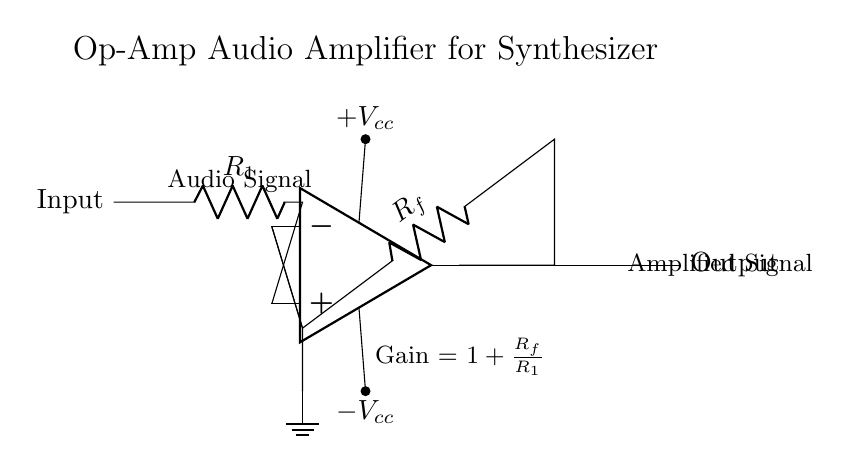What type of amplifier is shown in the circuit? The circuit depicts an operational amplifier, a component typically used for amplifying analog signals in various applications. It is specifically designed to perform mathematical operations on input signals, such as addition or amplification.
Answer: Operational amplifier What is the feedback resistor in the diagram? The feedback resistor is labeled as R_f in the circuit. Feedback resistors are crucial as they determine the gain of the amplifier circuit by creating a feedback loop from the output back to the inverting input.
Answer: R_f What is the value of the gain for this amplifier circuit? The gain of the amplifier can be calculated using the formula given in the circuit: Gain = 1 + (R_f / R_1). This relationship shows how the gain depends on the ratio of the feedback resistor to the input resistor.
Answer: 1 + (R_f / R_1) What type of signal is being amplified? The circuit is designed to amplify audio signals, which are typically in the frequency range that can be heard by humans, usually between 20 Hz to 20 kHz. This specific application makes it suitable for audio devices like synthesizers.
Answer: Audio Signal Where does the output of the op-amp connect in the circuit? The output of the operational amplifier is connected to the right side of the diagram, labeled as Output. This connection signifies that the amplified audio signal is available for further processing or sending to other audio equipment.
Answer: Output What are the power supply voltages indicated in the circuit? The power supply voltages are denoted as +V_cc and -V_cc, providing the necessary operational voltages for the op-amp to function correctly. These voltages are essential for enabling positive and negative signal processing within the amplifier.
Answer: +V_cc and -V_cc 